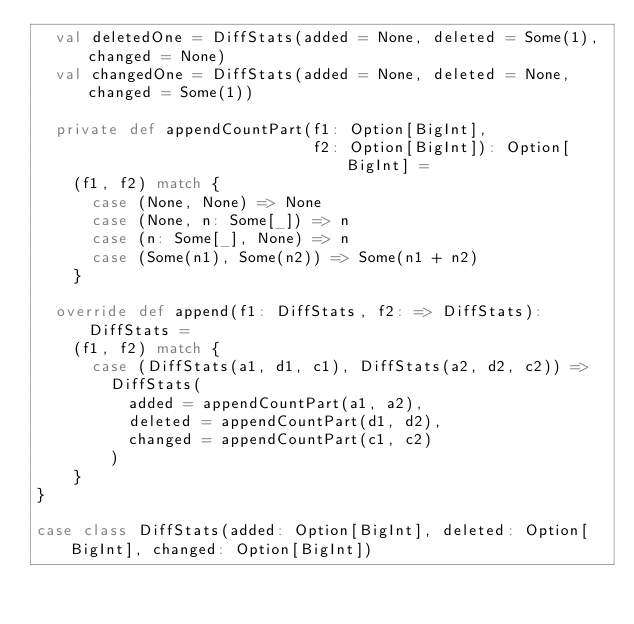Convert code to text. <code><loc_0><loc_0><loc_500><loc_500><_Scala_>  val deletedOne = DiffStats(added = None, deleted = Some(1), changed = None)
  val changedOne = DiffStats(added = None, deleted = None, changed = Some(1))

  private def appendCountPart(f1: Option[BigInt],
                              f2: Option[BigInt]): Option[BigInt] =
    (f1, f2) match {
      case (None, None) => None
      case (None, n: Some[_]) => n
      case (n: Some[_], None) => n
      case (Some(n1), Some(n2)) => Some(n1 + n2)
    }

  override def append(f1: DiffStats, f2: => DiffStats): DiffStats =
    (f1, f2) match {
      case (DiffStats(a1, d1, c1), DiffStats(a2, d2, c2)) =>
        DiffStats(
          added = appendCountPart(a1, a2),
          deleted = appendCountPart(d1, d2),
          changed = appendCountPart(c1, c2)
        )
    }
}

case class DiffStats(added: Option[BigInt], deleted: Option[BigInt], changed: Option[BigInt])</code> 